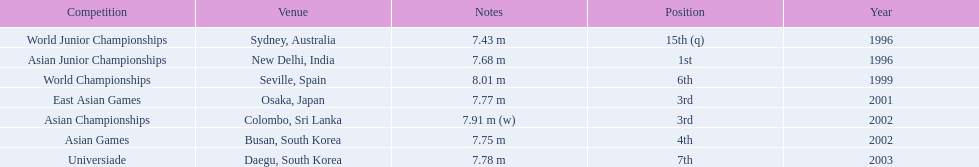Tell me the only venue in spain. Seville, Spain. 